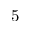<formula> <loc_0><loc_0><loc_500><loc_500>5</formula> 